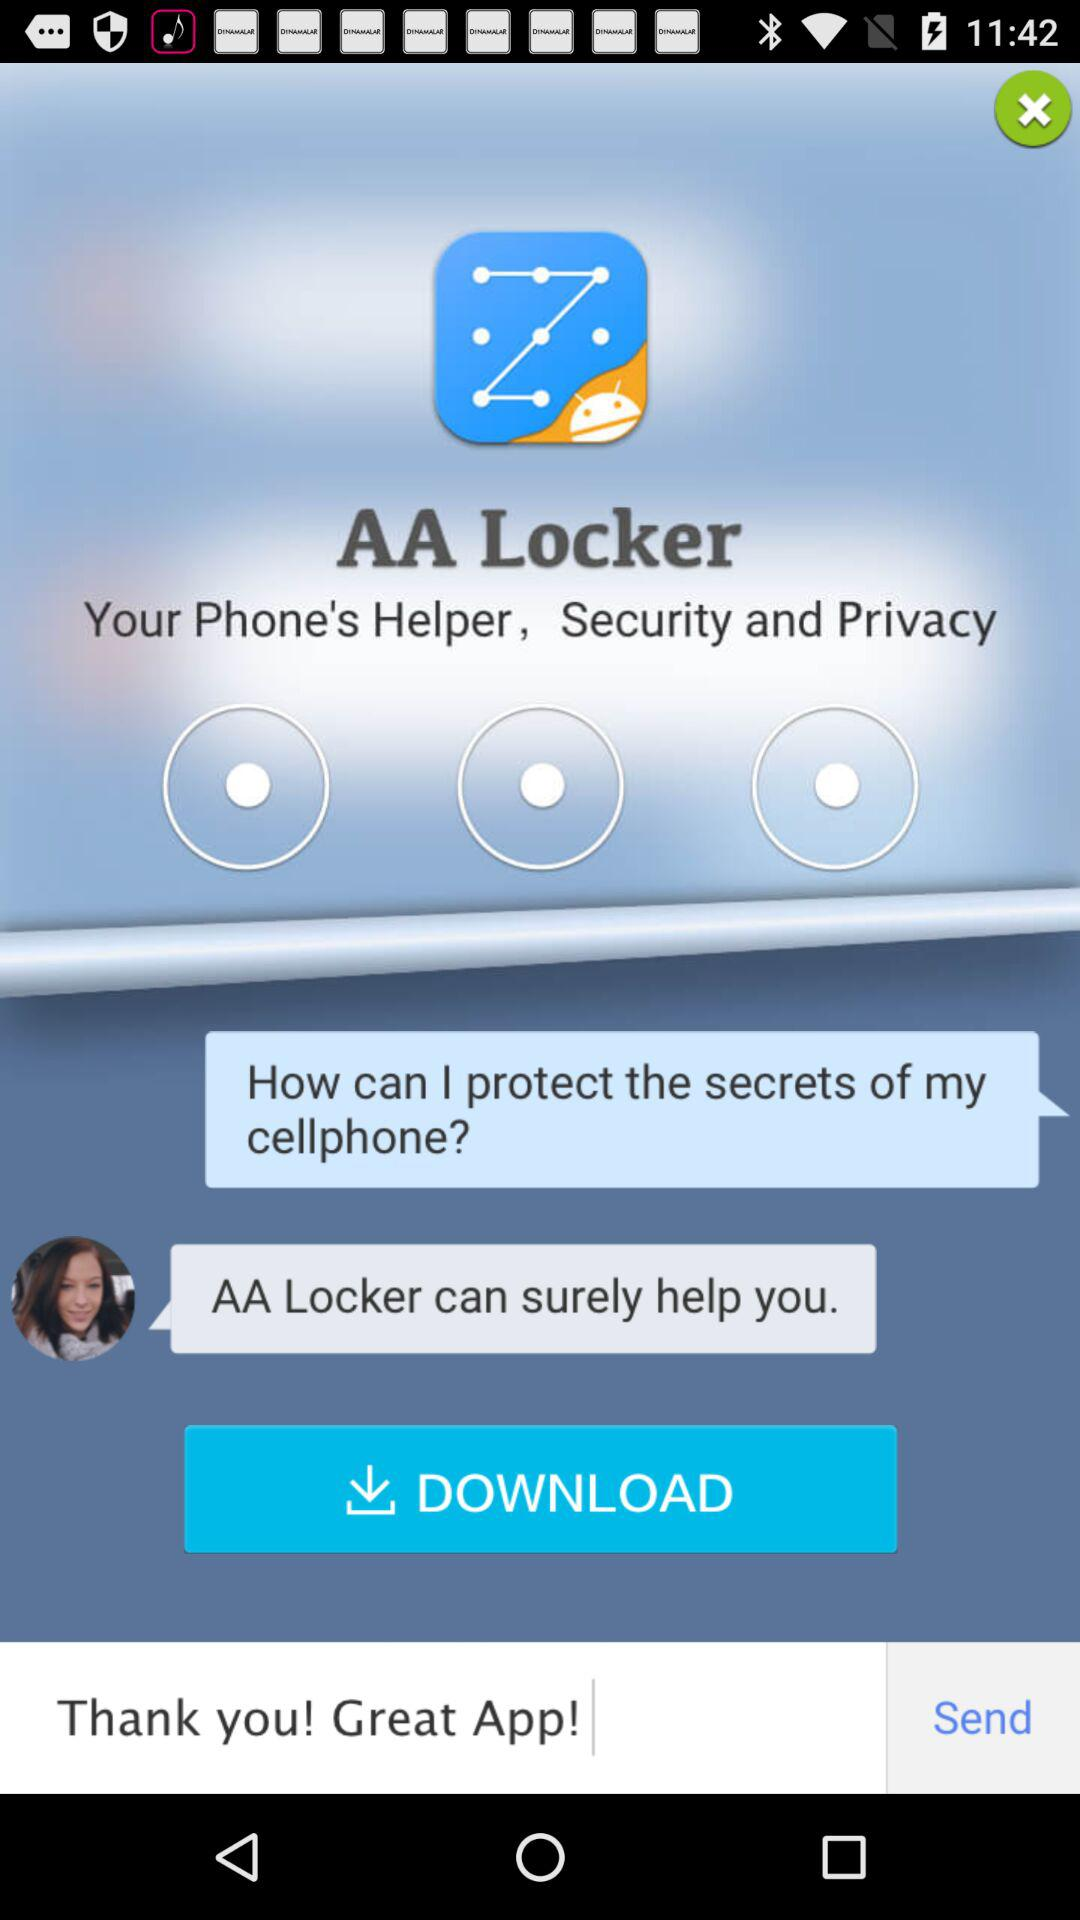What is the typed message? The typed message is "Thank you! Great App!". 